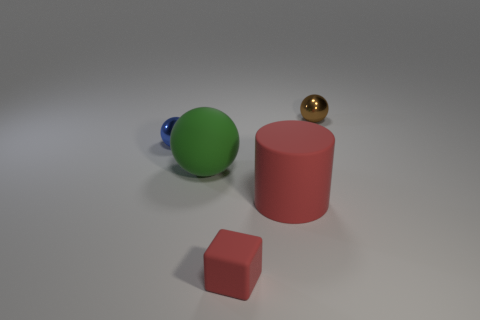Can you tell me the colors and shapes present in the image? Certainly! In the image, there is a large green ball, a small shiny gold ball, and a medium-sized red cylinder. Additionally, there's a small red cube on the front left side. Which object appears to be the largest? The largest object in the image is the red cylinder based on its visible dimensions compared to the other objects. 